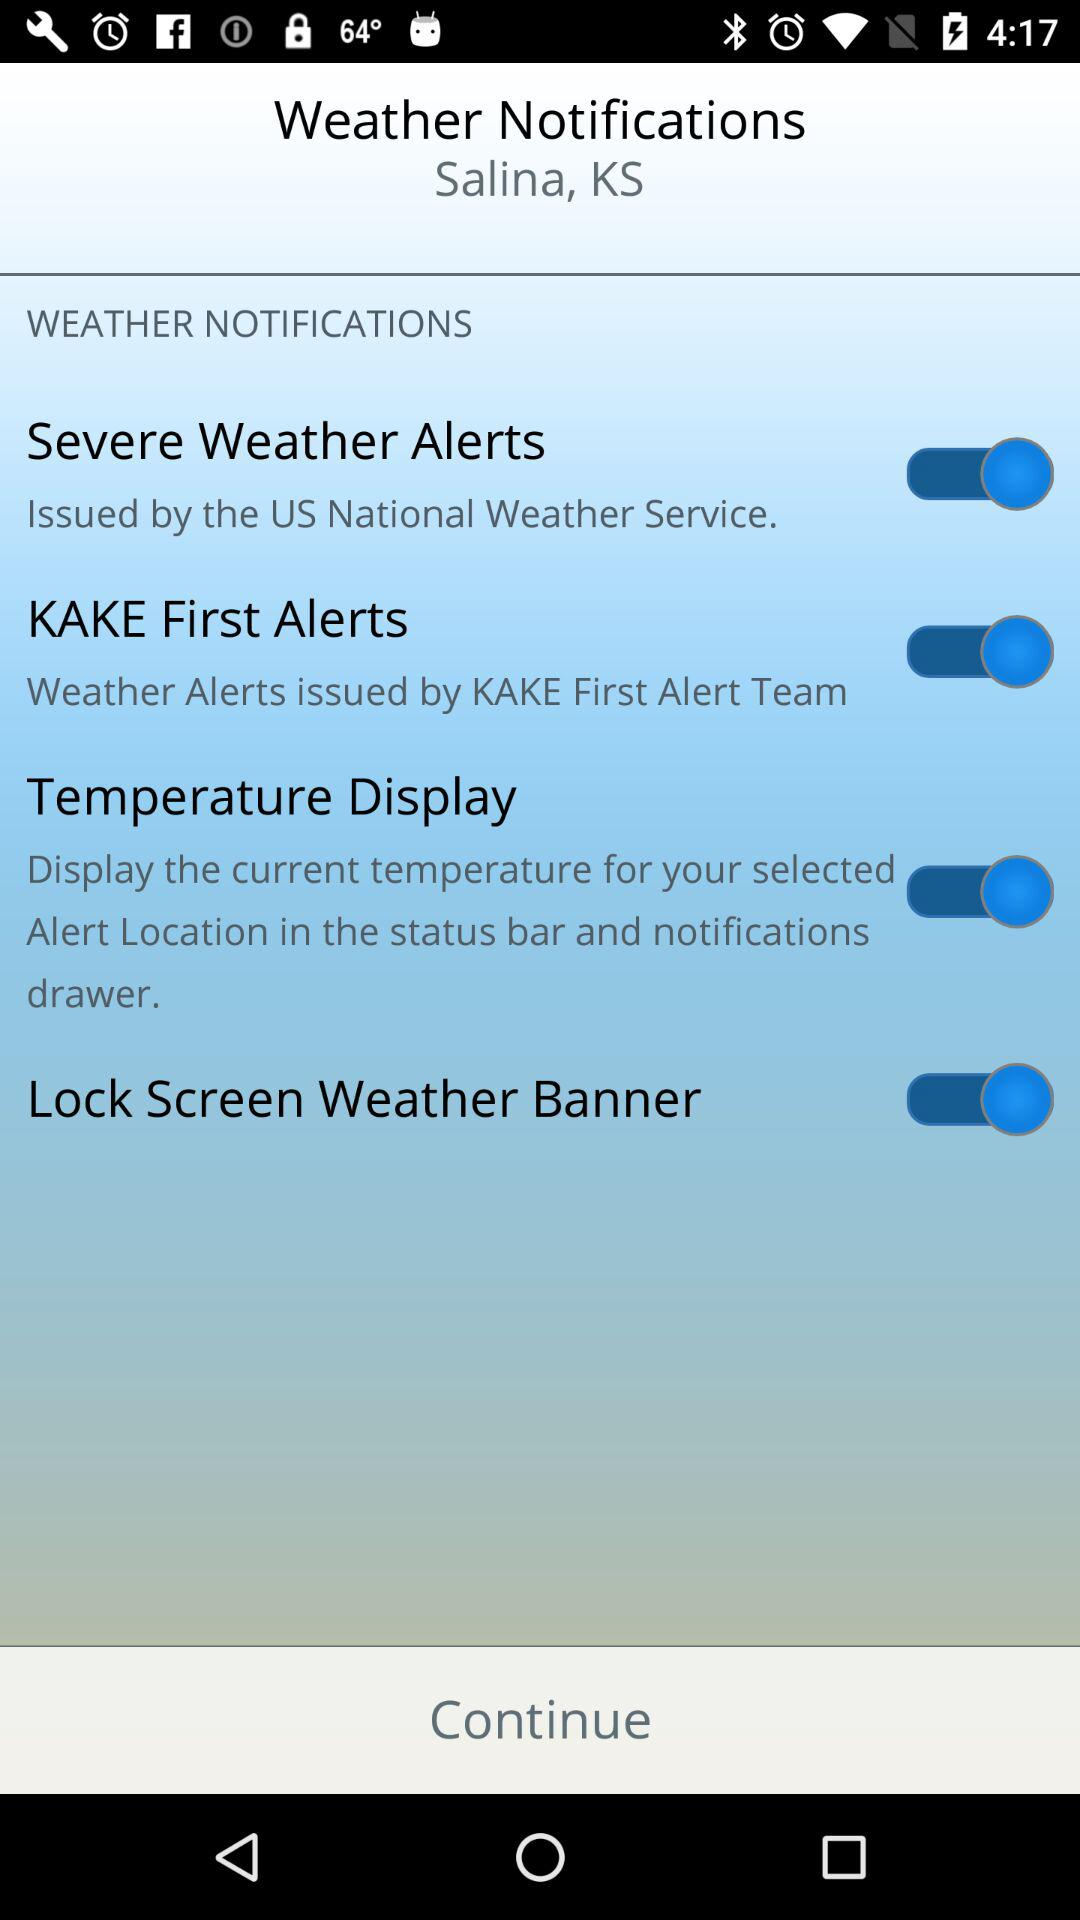What is the status of "Severe Weather Alerts"? The status is "on". 